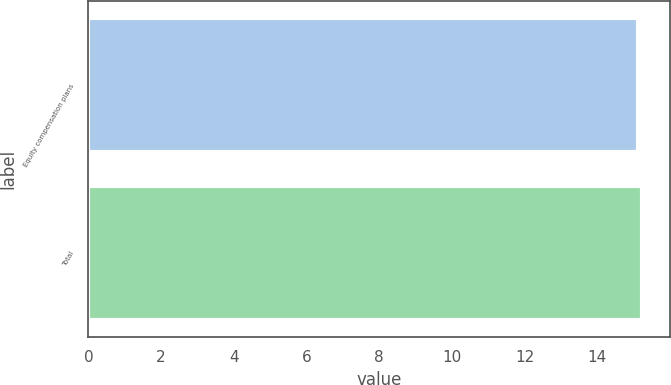Convert chart to OTSL. <chart><loc_0><loc_0><loc_500><loc_500><bar_chart><fcel>Equity compensation plans<fcel>Total<nl><fcel>15.13<fcel>15.23<nl></chart> 